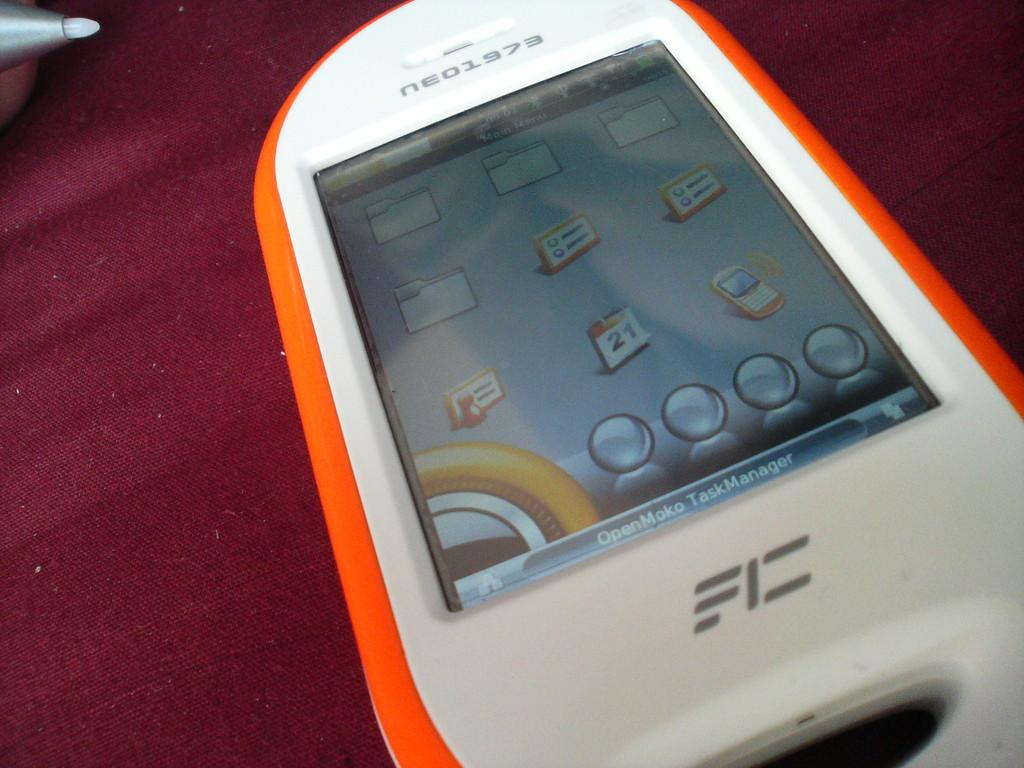<image>
Give a short and clear explanation of the subsequent image. A neo1973 phone is white with an orange rim. 